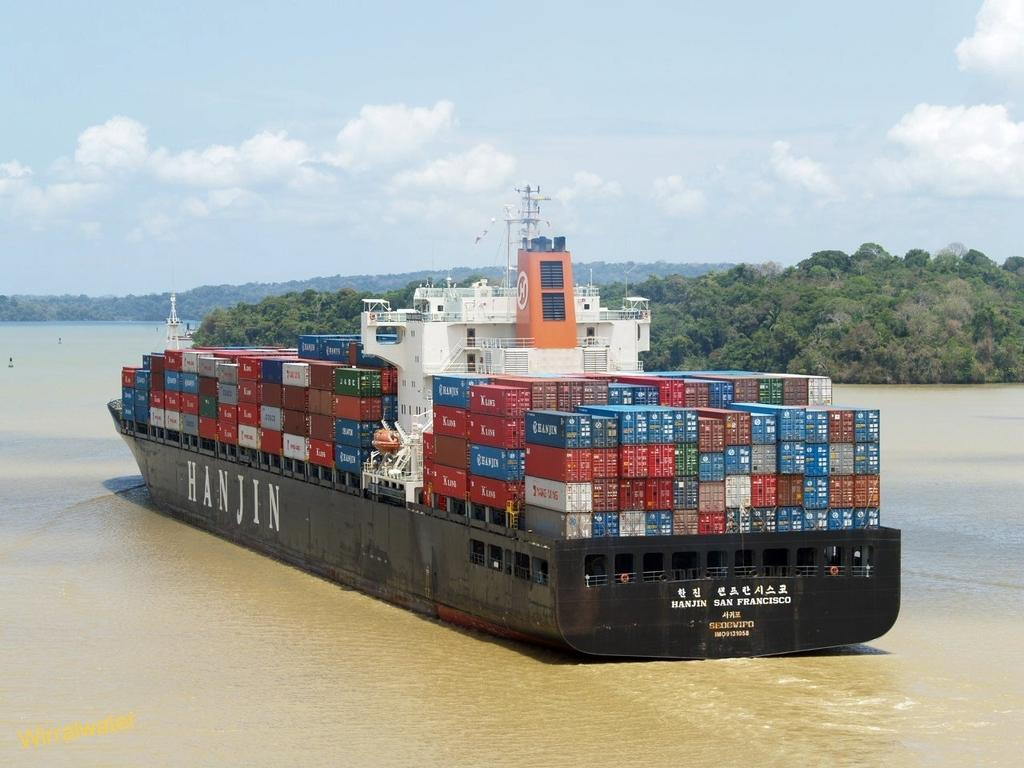What is the main subject of the image? The main subject of the image is a ship. What can be seen on the ship? The ship has boxes on it. Where is the ship located? The ship is on a river. What type of vegetation is on the right side of the image? There are trees on the right side of the image. What is visible in the background of the image? There are mountains and the sky visible in the background of the image. How many fingers can be seen on the ship in the image? There are no fingers visible on the ship in the image. Are there any bears visible in the image? There are no bears present in the image. 